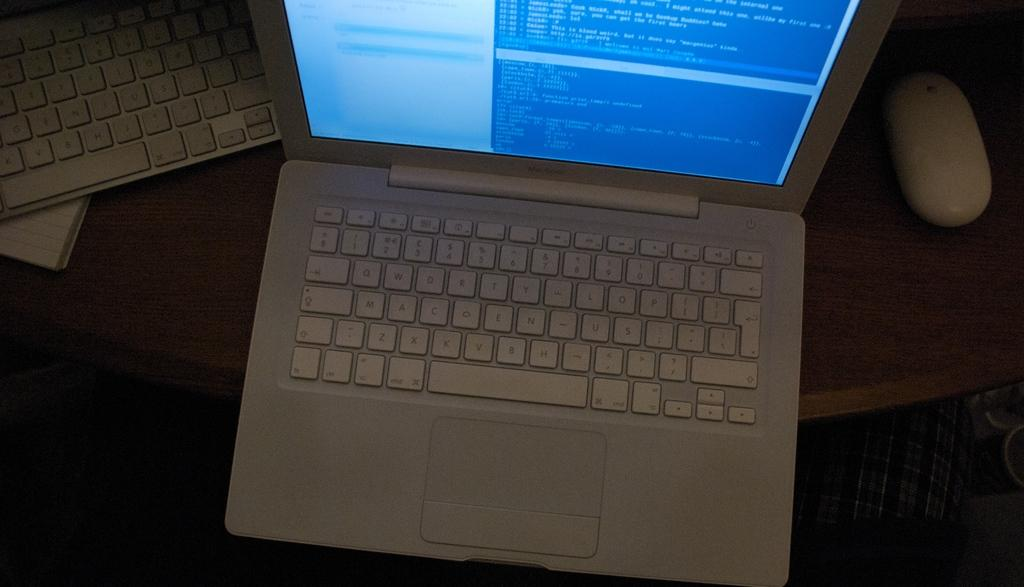What electronic devices are visible in the image? There are laptops in the image. What non-electronic item can be seen in the image? There is a book in the image. What accessory is used with the laptops? There is a mouse in the image. What piece of furniture is present in the image? There is a table in the image. What objects are located on the right at the bottom of the image? There are some objects on the right at the bottom of the image. What month is depicted in the image? There is no month depicted in the image; it is a still image of objects and devices. 